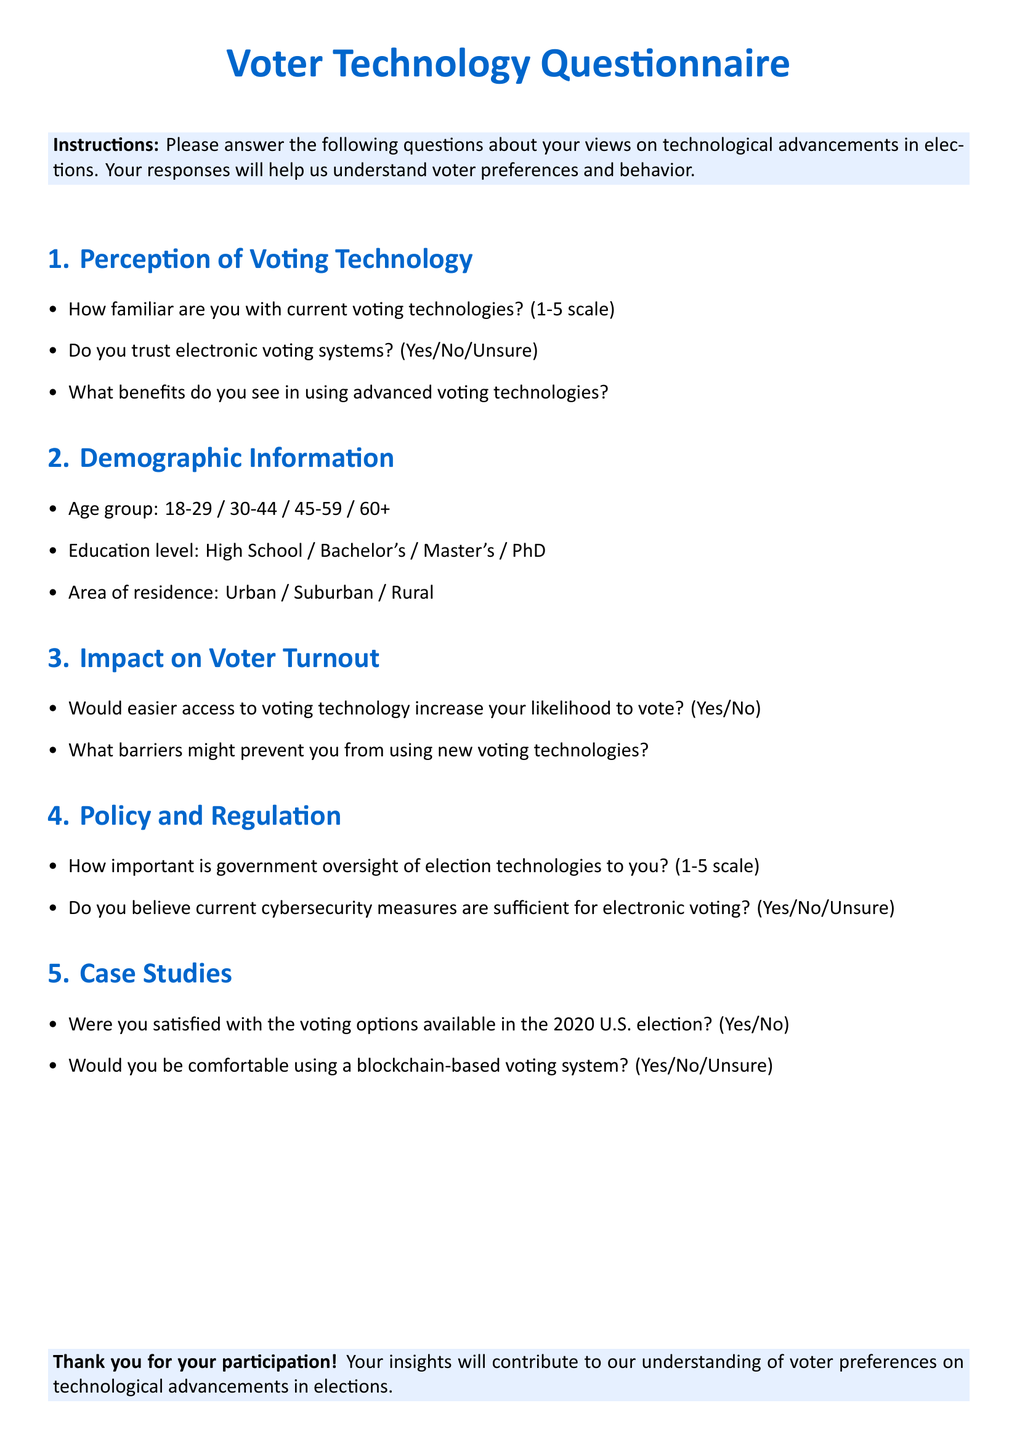What is the title of the questionnaire? The title is presented prominently at the top of the document and states the purpose of the document.
Answer: Voter Technology Questionnaire How many sections are in the questionnaire? The document includes five distinct sections that cover various aspects of voter behavior and preferences.
Answer: 5 What scale is used to measure familiarity with voting technologies? A standard scale is referenced in the first section for participants to express their familiarity with current voting technologies.
Answer: 1-5 scale What is one of the demographic information categories? The sections provide structured demographic categories for respondents, including various age groups.
Answer: Age group What is a barrier to using new voting technologies mentioned in the questionnaire? The document directly requests input on potential barriers respondents might face regarding the adoption of new voting technologies.
Answer: Barriers How does the questionnaire assess satisfaction with the 2020 U.S. election? The document includes a binary question aimed at gauging voters' satisfaction with the options provided during the election.
Answer: Yes/No What is the color used for important text in the title? The color scheme is specified in the document, highlighting significant text such as the title.
Answer: Main color How is government oversight of election technologies measured? A specific rating scale is used in the document to determine the importance of government oversight to respondents.
Answer: 1-5 scale 